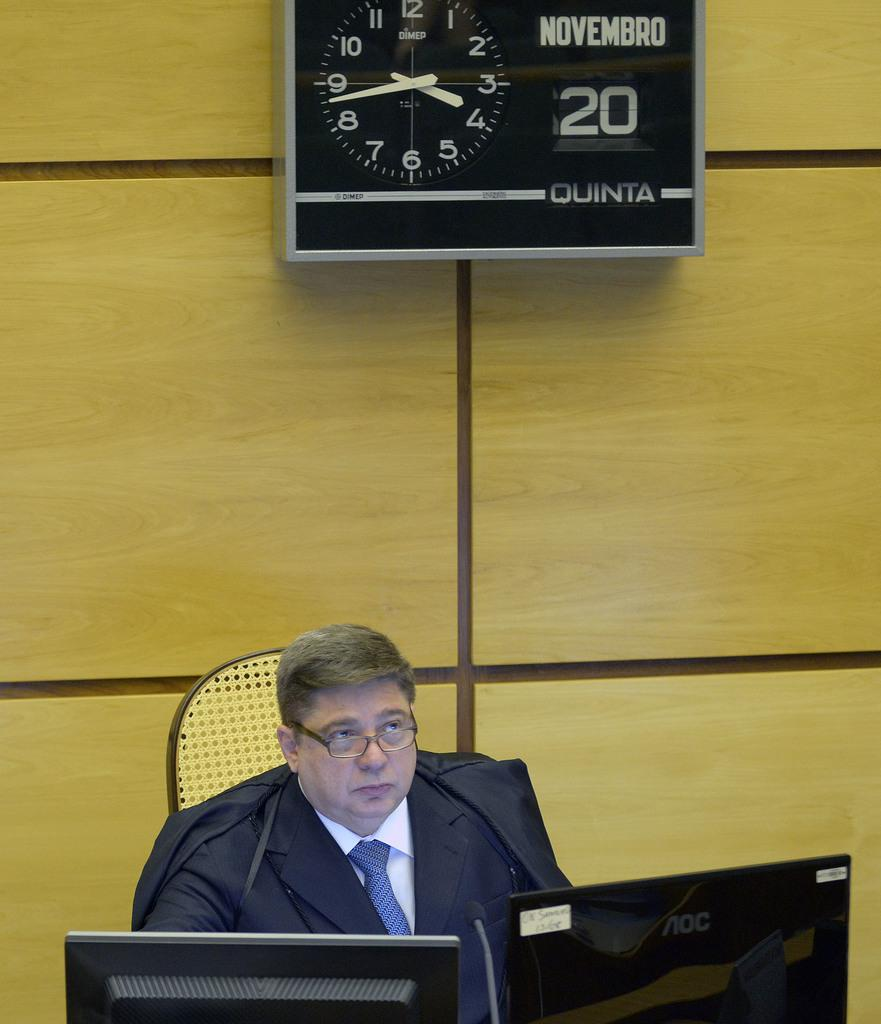Provide a one-sentence caption for the provided image. a man that is under a clock with the number 20 next to it. 